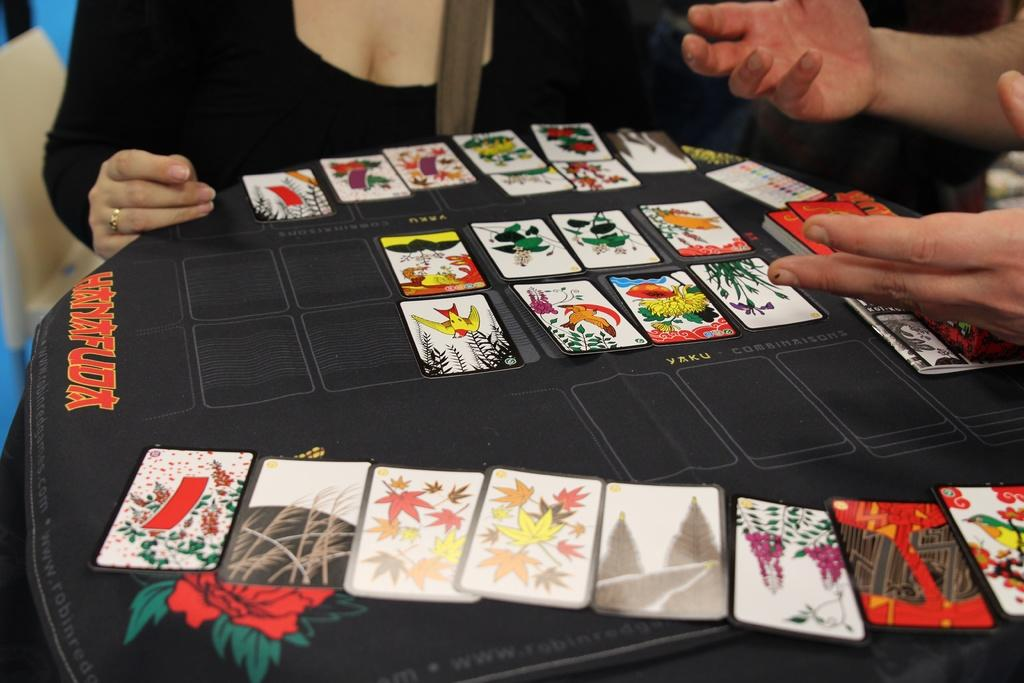Who is present in the image? There are people in the image. What are the people doing in the image? The people are sitting and playing cards. What object can be seen in the image that the people are using for their activity? There is a table in the image that the people are using for playing cards. How many cats are sitting on the table in the image? There are no cats present in the image; it features people playing cards at a table. What type of brass material can be seen in the image? There is no brass material present in the image. 